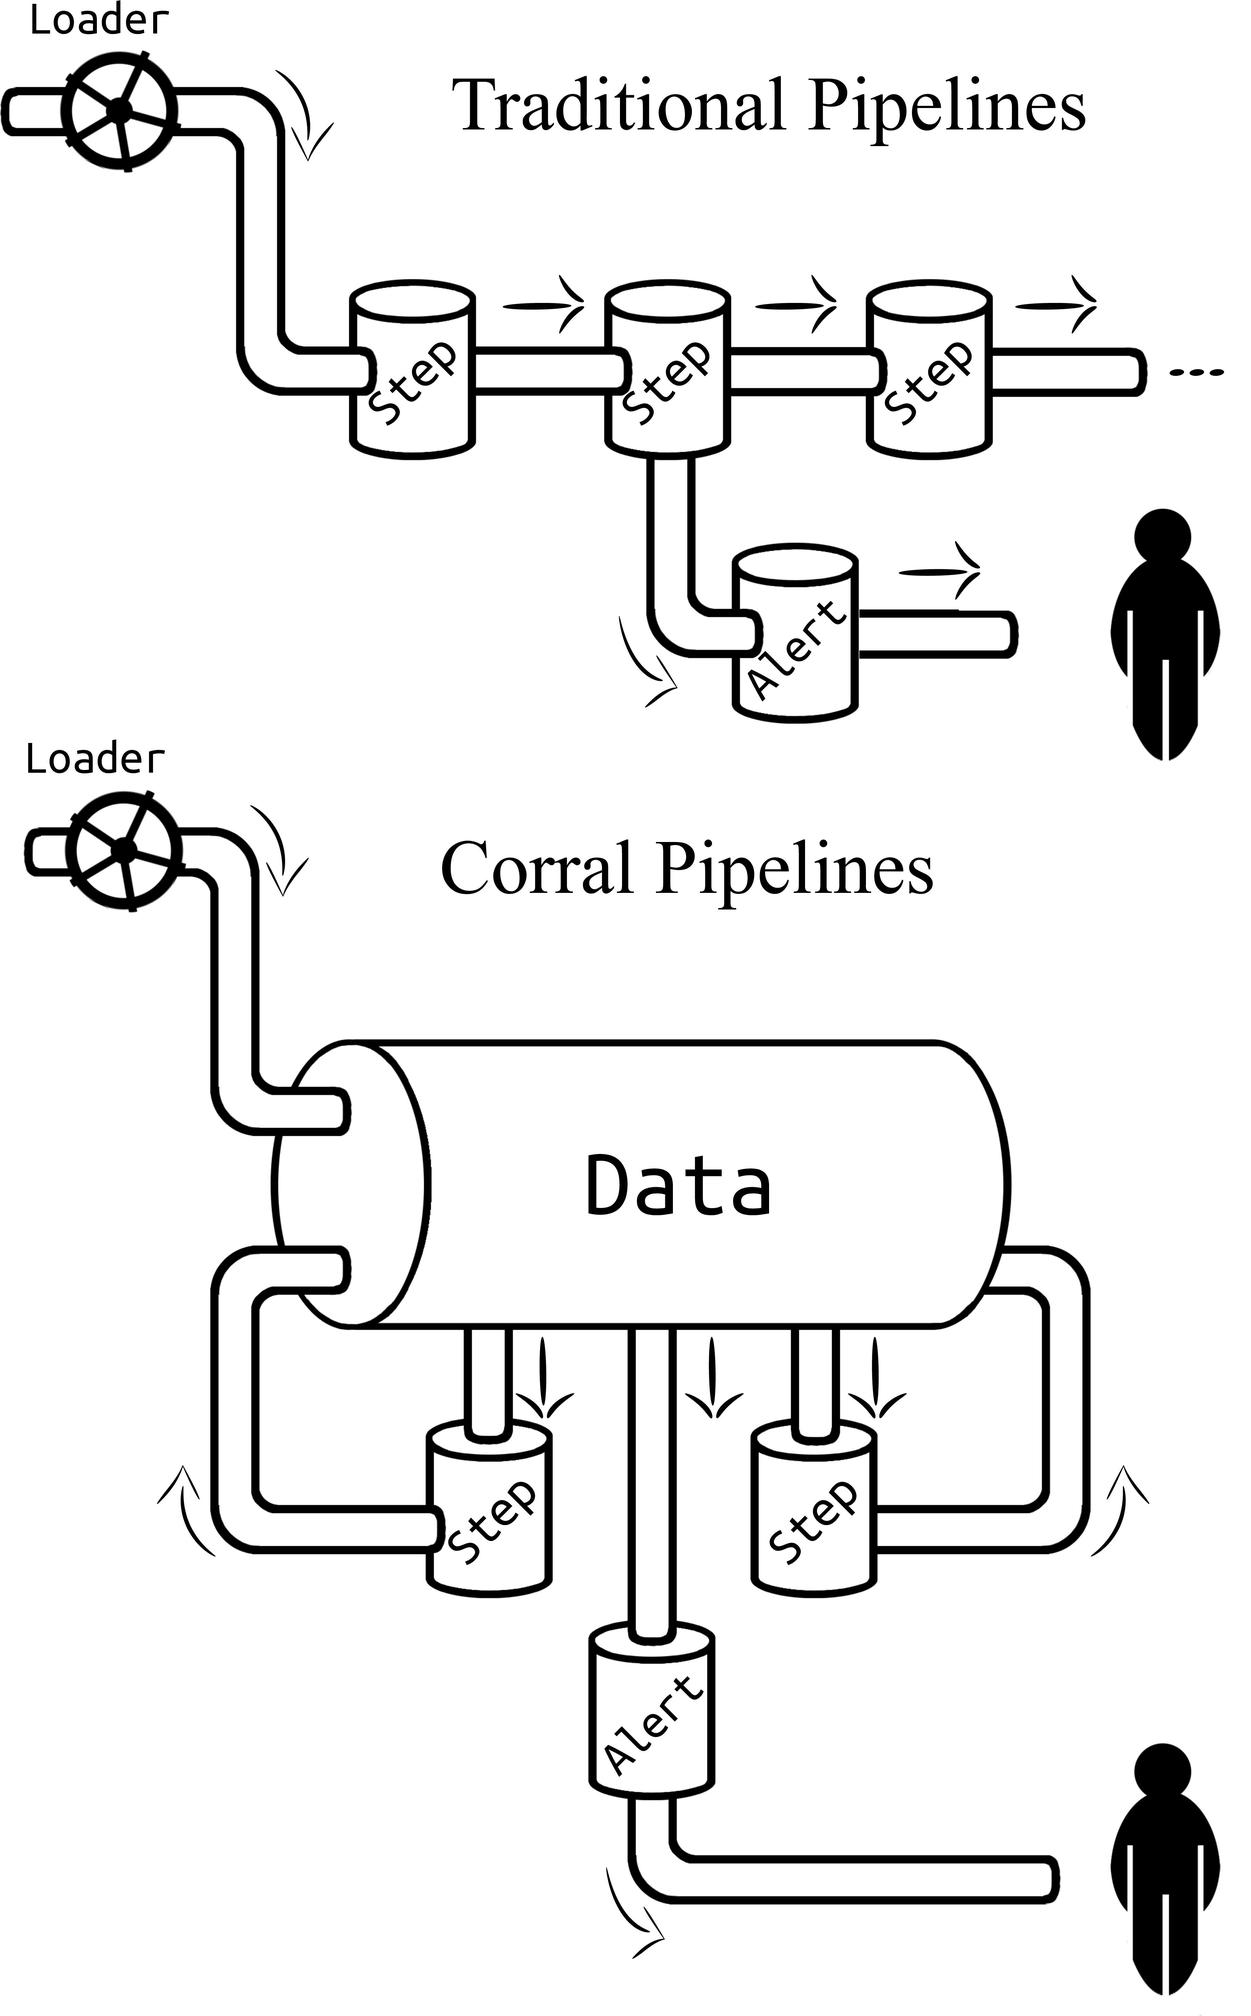What is the function of the "Alert" component in the pipelines? A. To stop the data processing B. To provide notifications on data processing status C. To load data into the pipeline D. To bypass the data processing steps The "Alert" is shown as a component branching out from the main flow in both pipeline diagrams, which typically indicates a notification or exception handling mechanism rather than a stop or a data loading function. Therefore, the correct answer is B. 